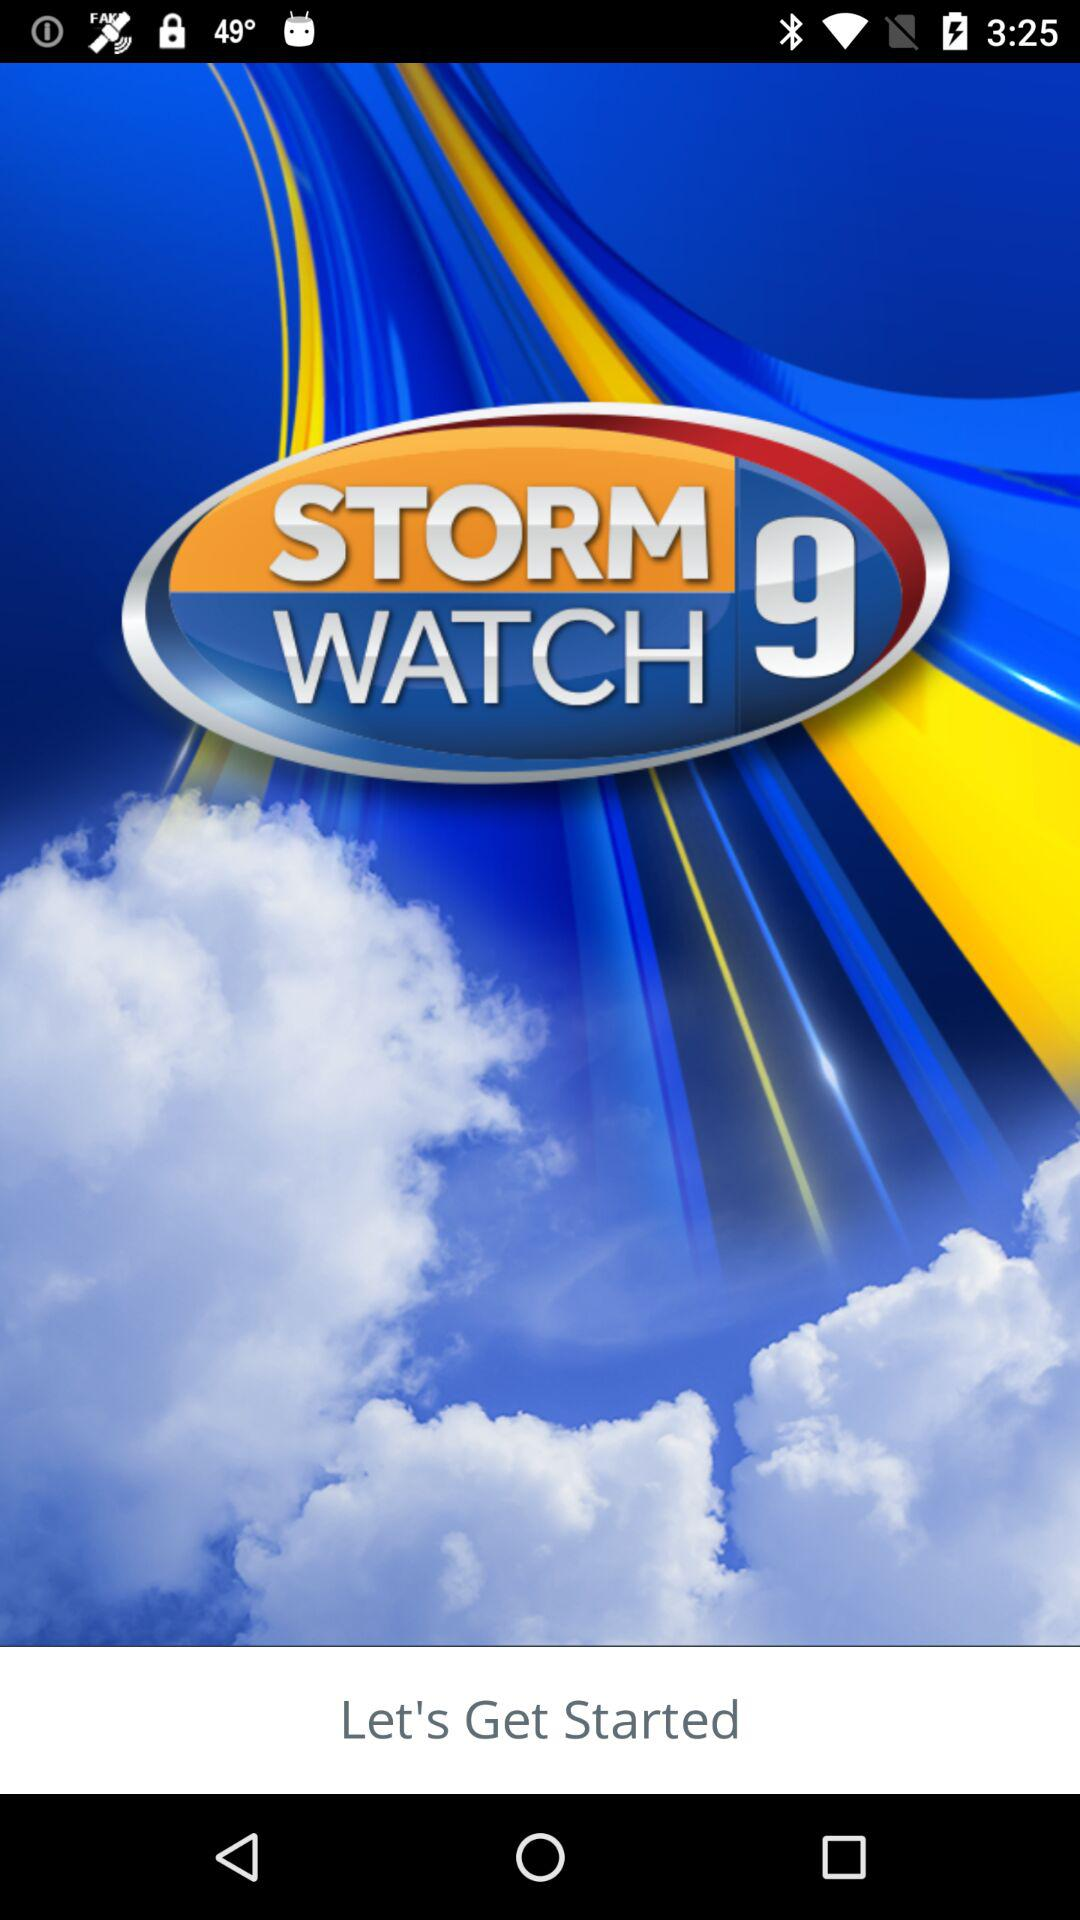How many people have downloaded the application?
When the provided information is insufficient, respond with <no answer>. <no answer> 